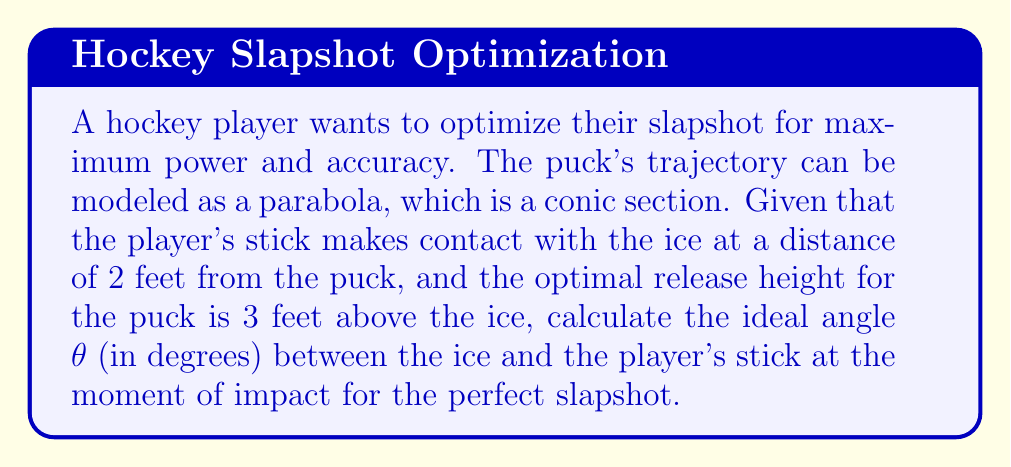Provide a solution to this math problem. Let's approach this step-by-step using trigonometry and the properties of parabolas:

1) The situation can be modeled as a right triangle, where:
   - The base of the triangle is 2 feet (distance from stick-ice contact to puck)
   - The height of the triangle is 3 feet (optimal release height)
   - The hypotenuse represents the player's stick
   - The angle θ is what we need to find

2) We can use the arctangent function to find this angle:

   $$θ = \arctan(\frac{\text{opposite}}{\text{adjacent}})$$

3) Substituting our known values:

   $$θ = \arctan(\frac{3}{2})$$

4) Calculate the result:

   $$θ = \arctan(1.5) \approx 0.982 \text{ radians}$$

5) Convert radians to degrees:

   $$θ \approx 0.982 \times \frac{180°}{\pi} \approx 56.31°$$

6) The parabolic trajectory of the puck after impact can be described by the equation:

   $$y = ax^2 + bx + c$$

   Where (0,0) is the point of impact, and (2,3) is the release point.

7) This angle ensures that the stick's motion aligns with the tangent line of the parabola at the point of impact, maximizing energy transfer and control.

[asy]
import geometry;

size(200);

pair A = (0,0);
pair B = (2,0);
pair C = (2,3);

draw(A--B--C--A);

label("2 ft", (1,0), S);
label("3 ft", (2,1.5), E);
label("θ", (0.3,0.3), NW);

draw(arc(A,0.5,0,56.31), Arrow);
[/asy]
Answer: $56.31°$ 